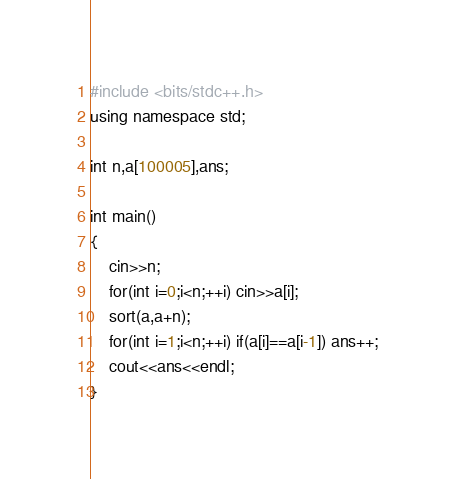Convert code to text. <code><loc_0><loc_0><loc_500><loc_500><_C++_>#include <bits/stdc++.h>
using namespace std;

int n,a[100005],ans;

int main()
{  	
	cin>>n;
	for(int i=0;i<n;++i) cin>>a[i];
	sort(a,a+n);
	for(int i=1;i<n;++i) if(a[i]==a[i-1]) ans++;
	cout<<ans<<endl;	
}	</code> 